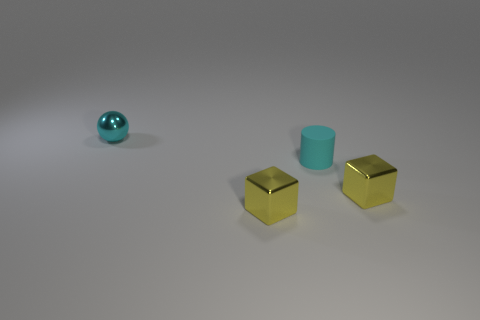What is the shape of the cyan object that is in front of the tiny cyan ball?
Your answer should be very brief. Cylinder. How many tiny cylinders are to the left of the small object that is in front of the thing that is to the right of the cyan cylinder?
Your response must be concise. 0. There is a metal cube that is to the left of the small matte object; is its color the same as the tiny rubber thing?
Make the answer very short. No. How many other things are there of the same shape as the small cyan rubber object?
Your response must be concise. 0. How many other objects are there of the same material as the small cylinder?
Provide a short and direct response. 0. What material is the cyan sphere that is to the left of the yellow metallic thing that is on the right side of the small yellow shiny object to the left of the cyan rubber object?
Offer a very short reply. Metal. What number of blocks are yellow objects or rubber things?
Provide a succinct answer. 2. There is a small cube that is on the left side of the matte cylinder; what is its color?
Ensure brevity in your answer.  Yellow. What number of metal things are either cyan cylinders or tiny blocks?
Give a very brief answer. 2. There is a cyan thing that is to the right of the small yellow thing on the left side of the cylinder; what is its material?
Give a very brief answer. Rubber. 